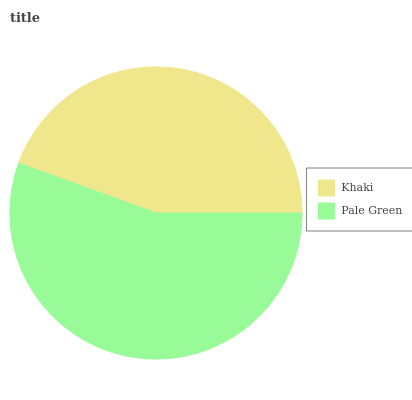Is Khaki the minimum?
Answer yes or no. Yes. Is Pale Green the maximum?
Answer yes or no. Yes. Is Pale Green the minimum?
Answer yes or no. No. Is Pale Green greater than Khaki?
Answer yes or no. Yes. Is Khaki less than Pale Green?
Answer yes or no. Yes. Is Khaki greater than Pale Green?
Answer yes or no. No. Is Pale Green less than Khaki?
Answer yes or no. No. Is Pale Green the high median?
Answer yes or no. Yes. Is Khaki the low median?
Answer yes or no. Yes. Is Khaki the high median?
Answer yes or no. No. Is Pale Green the low median?
Answer yes or no. No. 